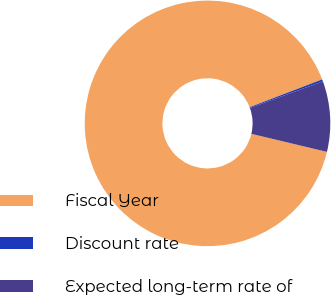<chart> <loc_0><loc_0><loc_500><loc_500><pie_chart><fcel>Fiscal Year<fcel>Discount rate<fcel>Expected long-term rate of<nl><fcel>90.44%<fcel>0.27%<fcel>9.29%<nl></chart> 